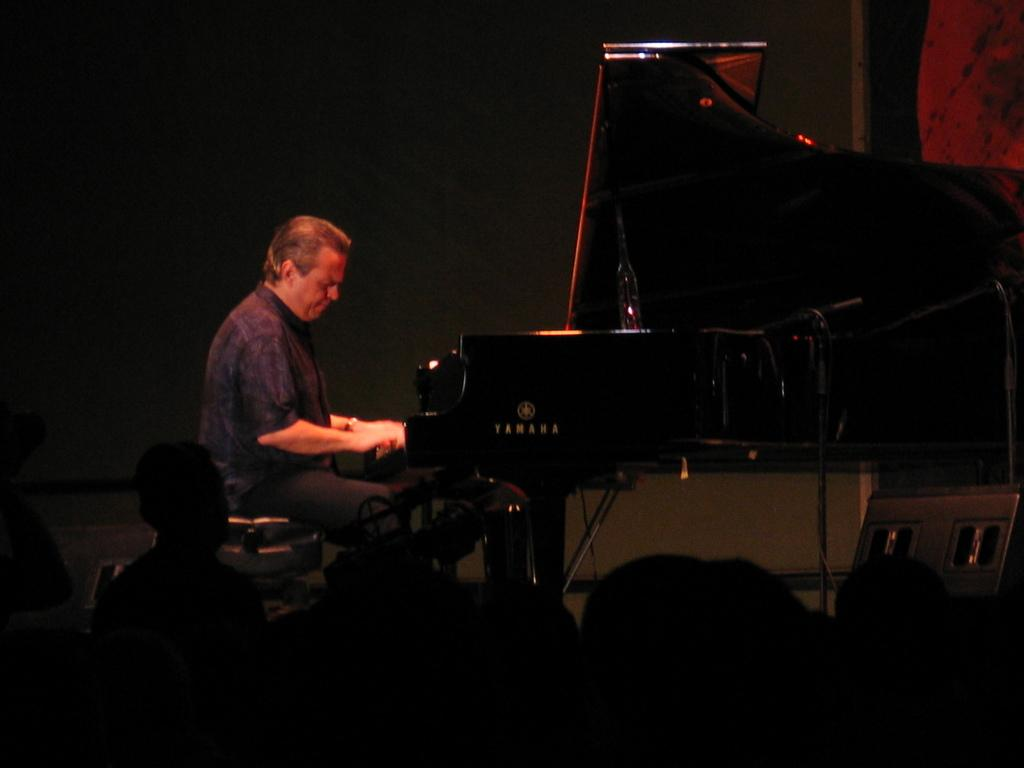What is the person in the image doing? The person is sitting on a table and playing a piano. Where is the piano located in relation to the person? The piano is in front of the person. Are there any other people present in the image? Yes, there are people watching the person play the piano. What type of collar can be seen on the person playing the piano? There is no collar visible on the person playing the piano in the image. What meal is being served to the audience in the image? There is no meal being served in the image; it features a person playing the piano with an audience watching. 